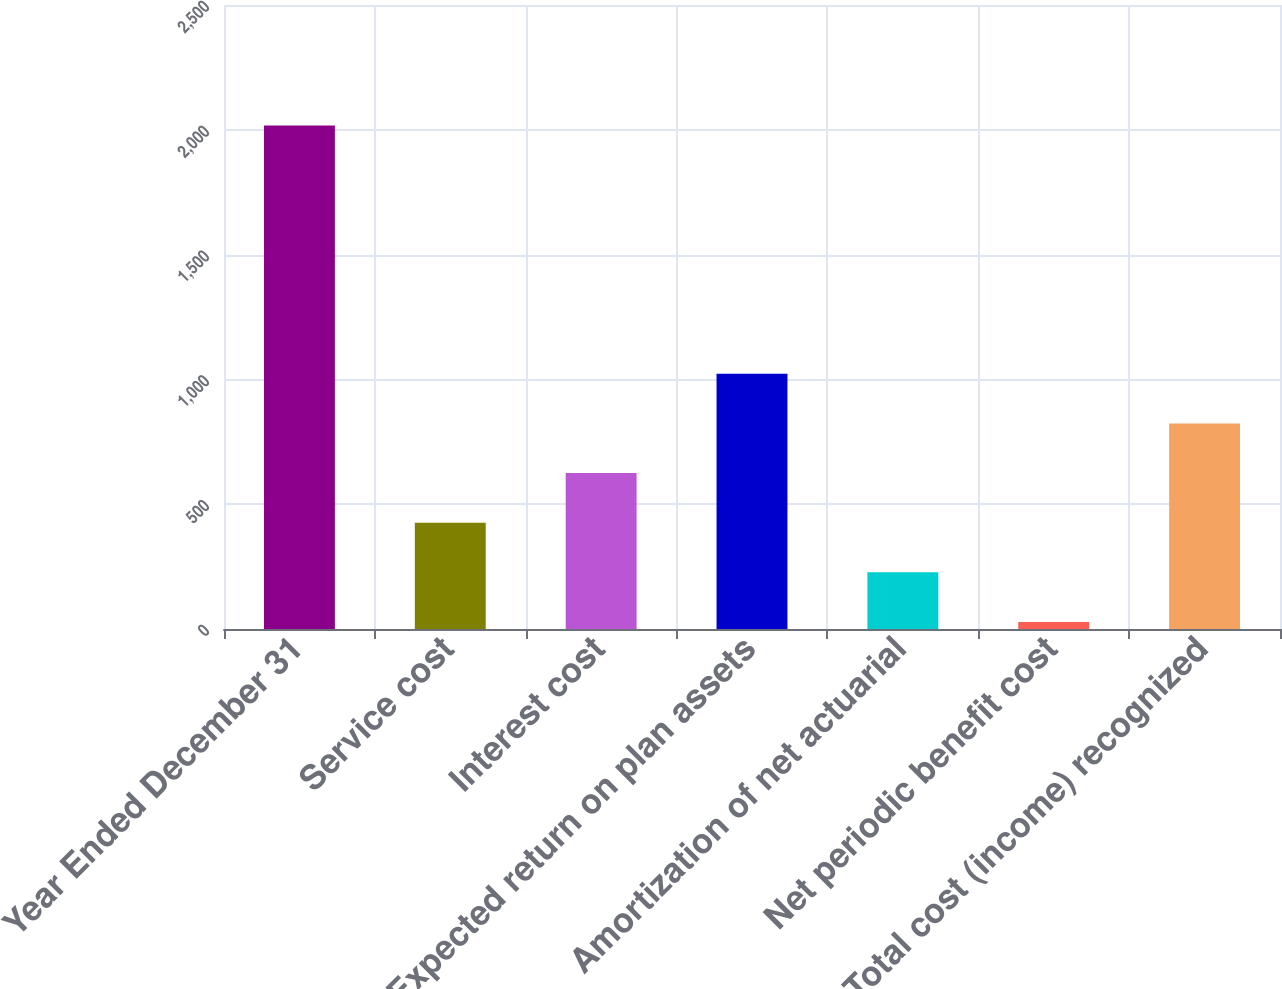Convert chart. <chart><loc_0><loc_0><loc_500><loc_500><bar_chart><fcel>Year Ended December 31<fcel>Service cost<fcel>Interest cost<fcel>Expected return on plan assets<fcel>Amortization of net actuarial<fcel>Net periodic benefit cost<fcel>Total cost (income) recognized<nl><fcel>2017<fcel>425.8<fcel>624.7<fcel>1022.5<fcel>226.9<fcel>28<fcel>823.6<nl></chart> 